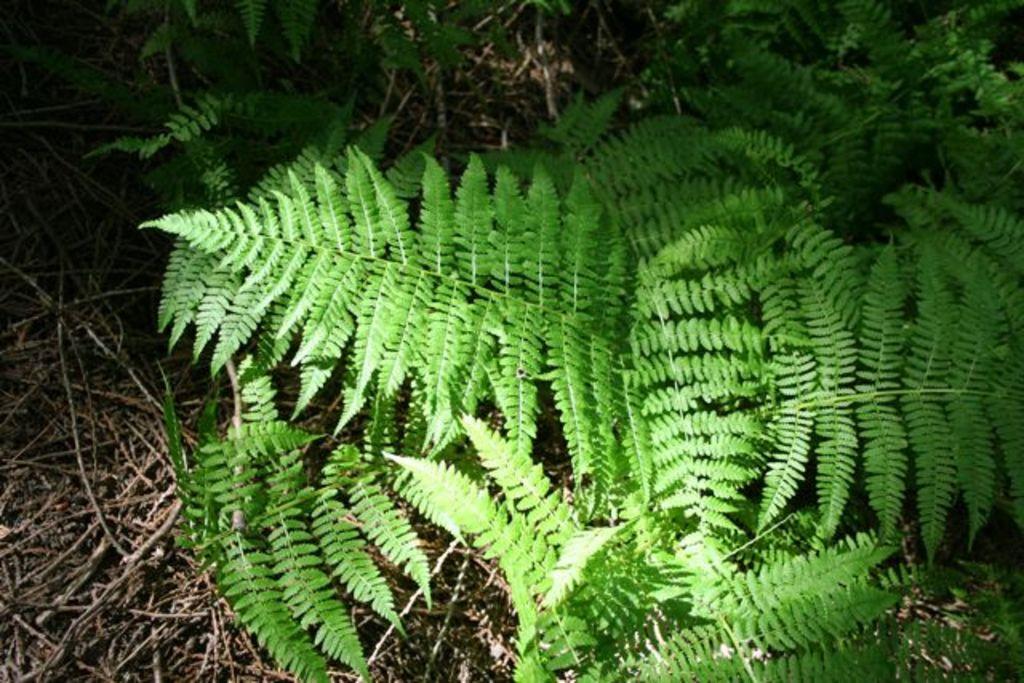Please provide a concise description of this image. In this image I can see few green plants and few sticks. 